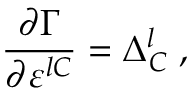<formula> <loc_0><loc_0><loc_500><loc_500>\frac { \partial \Gamma } { \partial \varepsilon ^ { l C } } = \Delta _ { C } ^ { l } \, ,</formula> 